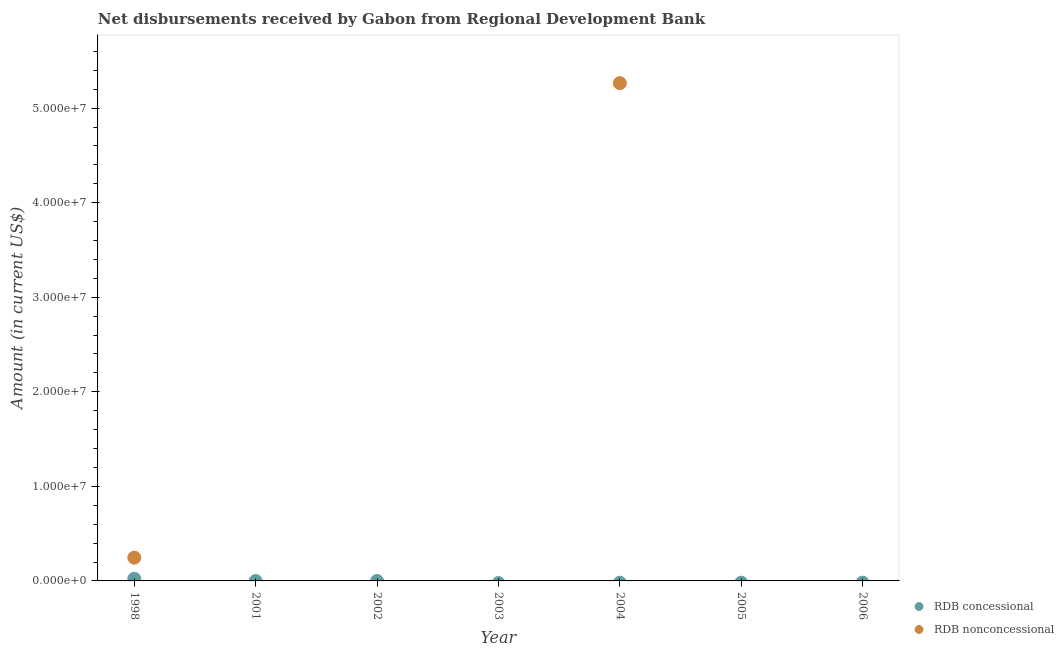How many different coloured dotlines are there?
Provide a short and direct response. 2. What is the net concessional disbursements from rdb in 1998?
Your response must be concise. 2.27e+05. Across all years, what is the maximum net concessional disbursements from rdb?
Your answer should be very brief. 2.27e+05. What is the total net concessional disbursements from rdb in the graph?
Make the answer very short. 2.27e+05. What is the difference between the net non concessional disbursements from rdb in 2003 and the net concessional disbursements from rdb in 2002?
Your response must be concise. 0. What is the average net concessional disbursements from rdb per year?
Offer a terse response. 3.24e+04. In the year 1998, what is the difference between the net concessional disbursements from rdb and net non concessional disbursements from rdb?
Give a very brief answer. -2.23e+06. In how many years, is the net concessional disbursements from rdb greater than 28000000 US$?
Offer a terse response. 0. What is the difference between the highest and the lowest net non concessional disbursements from rdb?
Offer a terse response. 5.26e+07. In how many years, is the net concessional disbursements from rdb greater than the average net concessional disbursements from rdb taken over all years?
Keep it short and to the point. 1. Does the net concessional disbursements from rdb monotonically increase over the years?
Give a very brief answer. No. Is the net non concessional disbursements from rdb strictly greater than the net concessional disbursements from rdb over the years?
Offer a very short reply. No. Is the net non concessional disbursements from rdb strictly less than the net concessional disbursements from rdb over the years?
Offer a terse response. No. What is the difference between two consecutive major ticks on the Y-axis?
Your answer should be very brief. 1.00e+07. How are the legend labels stacked?
Provide a short and direct response. Vertical. What is the title of the graph?
Your answer should be very brief. Net disbursements received by Gabon from Regional Development Bank. What is the label or title of the Y-axis?
Your answer should be compact. Amount (in current US$). What is the Amount (in current US$) of RDB concessional in 1998?
Provide a succinct answer. 2.27e+05. What is the Amount (in current US$) of RDB nonconcessional in 1998?
Make the answer very short. 2.46e+06. What is the Amount (in current US$) in RDB concessional in 2001?
Ensure brevity in your answer.  0. What is the Amount (in current US$) in RDB nonconcessional in 2001?
Your answer should be very brief. 0. What is the Amount (in current US$) in RDB concessional in 2002?
Your answer should be compact. 0. What is the Amount (in current US$) in RDB nonconcessional in 2002?
Keep it short and to the point. 0. What is the Amount (in current US$) in RDB nonconcessional in 2004?
Provide a short and direct response. 5.26e+07. What is the Amount (in current US$) of RDB concessional in 2005?
Offer a very short reply. 0. What is the Amount (in current US$) in RDB nonconcessional in 2005?
Offer a very short reply. 0. What is the Amount (in current US$) in RDB nonconcessional in 2006?
Keep it short and to the point. 0. Across all years, what is the maximum Amount (in current US$) of RDB concessional?
Your answer should be compact. 2.27e+05. Across all years, what is the maximum Amount (in current US$) in RDB nonconcessional?
Give a very brief answer. 5.26e+07. Across all years, what is the minimum Amount (in current US$) in RDB concessional?
Offer a terse response. 0. Across all years, what is the minimum Amount (in current US$) in RDB nonconcessional?
Offer a very short reply. 0. What is the total Amount (in current US$) of RDB concessional in the graph?
Keep it short and to the point. 2.27e+05. What is the total Amount (in current US$) of RDB nonconcessional in the graph?
Keep it short and to the point. 5.51e+07. What is the difference between the Amount (in current US$) in RDB nonconcessional in 1998 and that in 2004?
Ensure brevity in your answer.  -5.02e+07. What is the difference between the Amount (in current US$) in RDB concessional in 1998 and the Amount (in current US$) in RDB nonconcessional in 2004?
Your response must be concise. -5.24e+07. What is the average Amount (in current US$) of RDB concessional per year?
Offer a very short reply. 3.24e+04. What is the average Amount (in current US$) of RDB nonconcessional per year?
Provide a short and direct response. 7.87e+06. In the year 1998, what is the difference between the Amount (in current US$) of RDB concessional and Amount (in current US$) of RDB nonconcessional?
Offer a very short reply. -2.23e+06. What is the ratio of the Amount (in current US$) of RDB nonconcessional in 1998 to that in 2004?
Offer a terse response. 0.05. What is the difference between the highest and the lowest Amount (in current US$) of RDB concessional?
Your response must be concise. 2.27e+05. What is the difference between the highest and the lowest Amount (in current US$) in RDB nonconcessional?
Offer a terse response. 5.26e+07. 